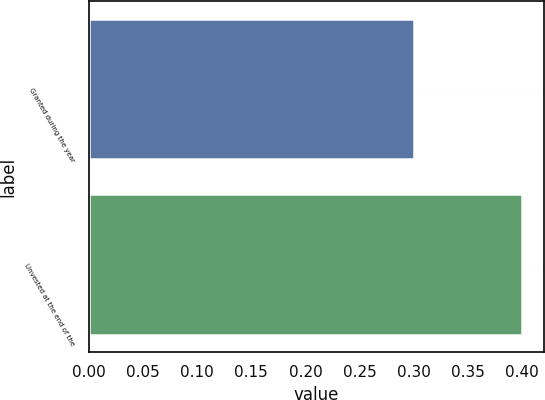Convert chart to OTSL. <chart><loc_0><loc_0><loc_500><loc_500><bar_chart><fcel>Granted during the year<fcel>Unvested at the end of the<nl><fcel>0.3<fcel>0.4<nl></chart> 